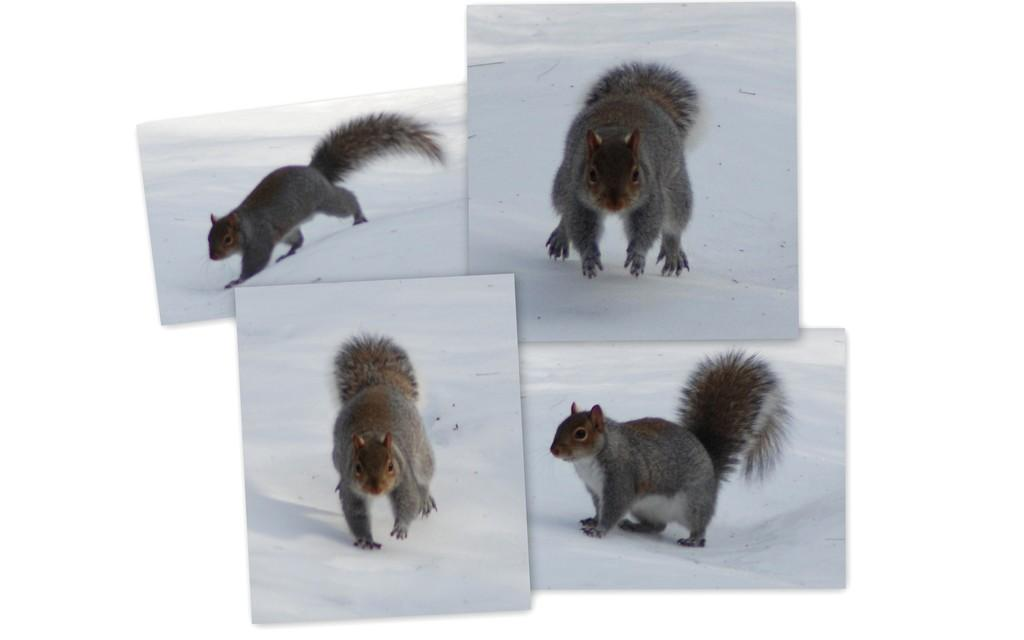What is the main subject of the image? The image contains a collage of images. Can you identify any specific elements within the collage? Yes, the collage features a squirrel. What is the setting or environment in which the squirrel is depicted? The squirrel is in the snow. What type of salt can be seen being used by the squirrel in the image? There is no salt present in the image, and the squirrel is not using any salt. How does the turkey fit into the image? There is no turkey present in the image. 